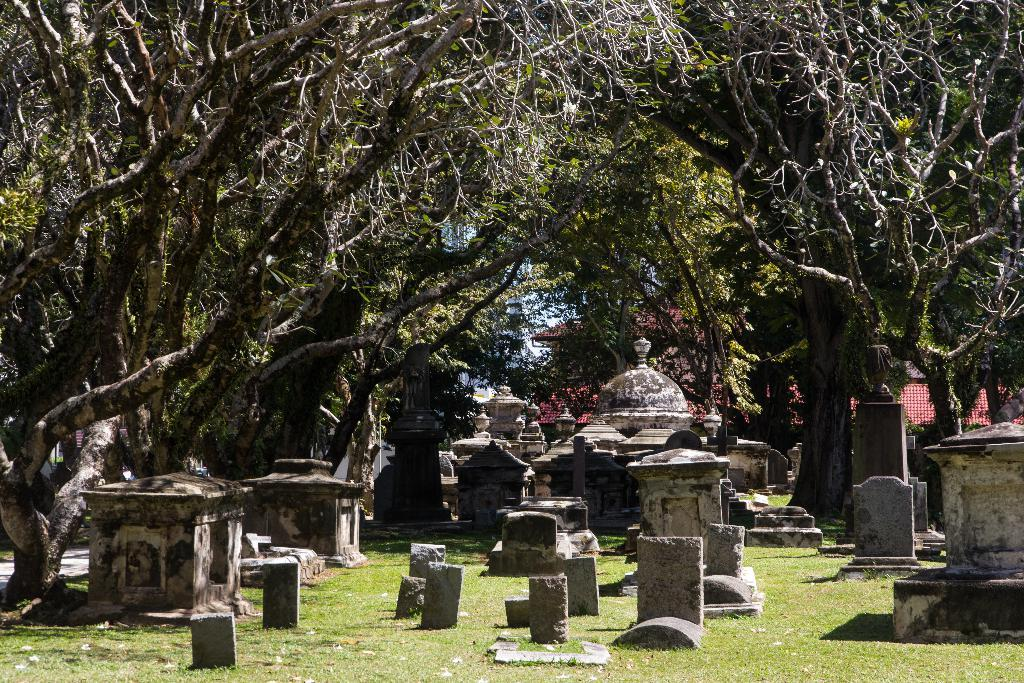What type of location is depicted in the image? The image contains cemeteries. What can be seen in the background of the image? There are trees and buildings in the background of the image. What is the color of the trees in the image? The trees in the image are green. What is the color of the sky in the image? The sky is blue in the image. Can you tell me the position of the stick in the image? There is no stick present in the image. How does the steam affect the appearance of the cemeteries in the image? There is no steam present in the image. 